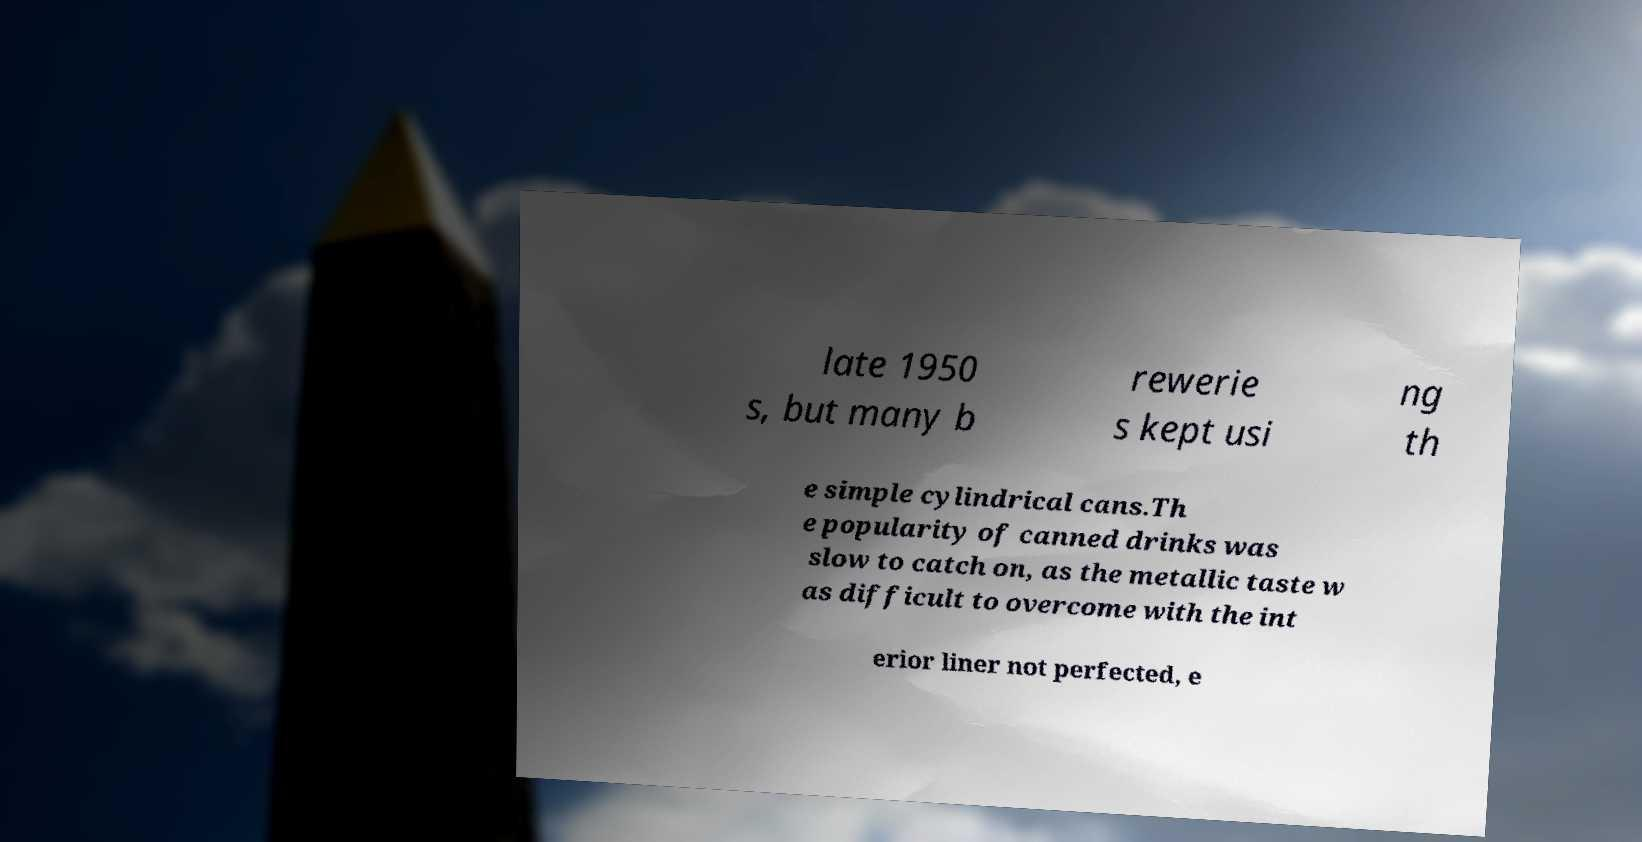Could you assist in decoding the text presented in this image and type it out clearly? late 1950 s, but many b rewerie s kept usi ng th e simple cylindrical cans.Th e popularity of canned drinks was slow to catch on, as the metallic taste w as difficult to overcome with the int erior liner not perfected, e 